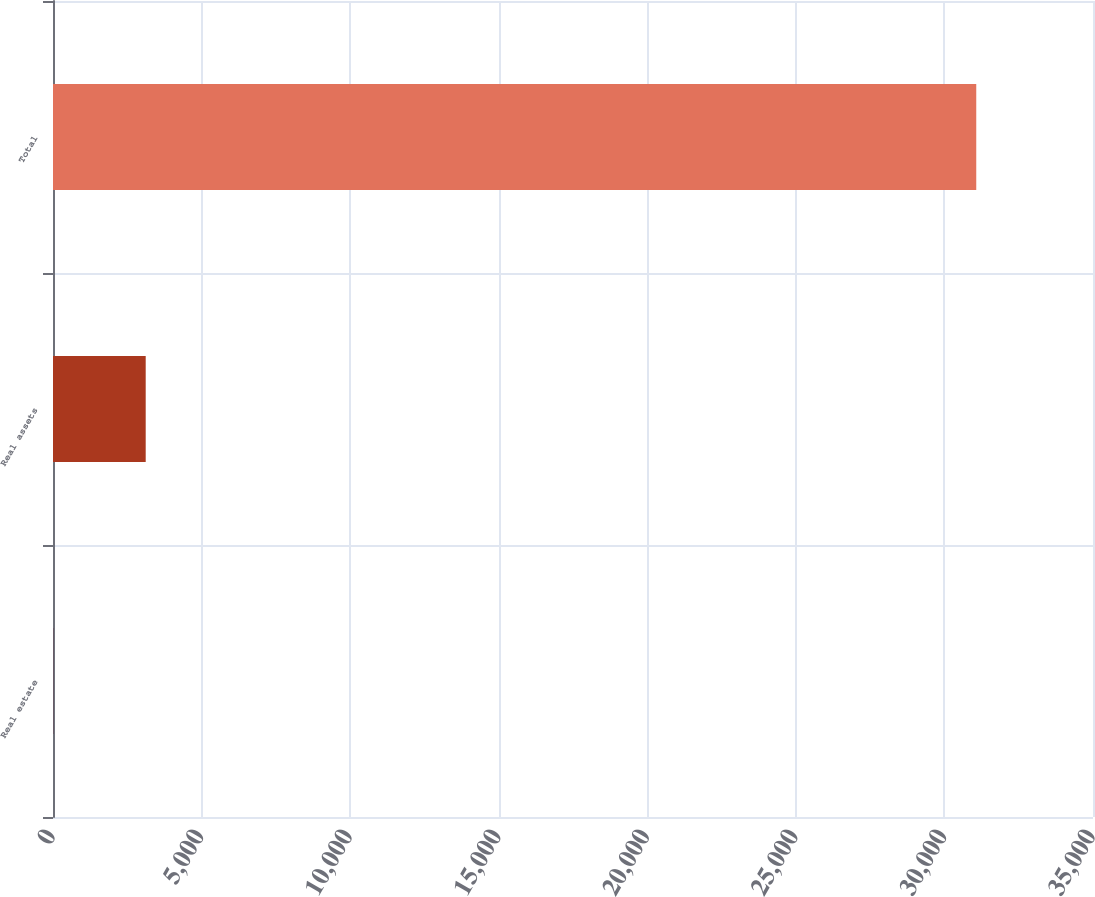Convert chart to OTSL. <chart><loc_0><loc_0><loc_500><loc_500><bar_chart><fcel>Real estate<fcel>Real assets<fcel>Total<nl><fcel>14<fcel>3119.7<fcel>31071<nl></chart> 